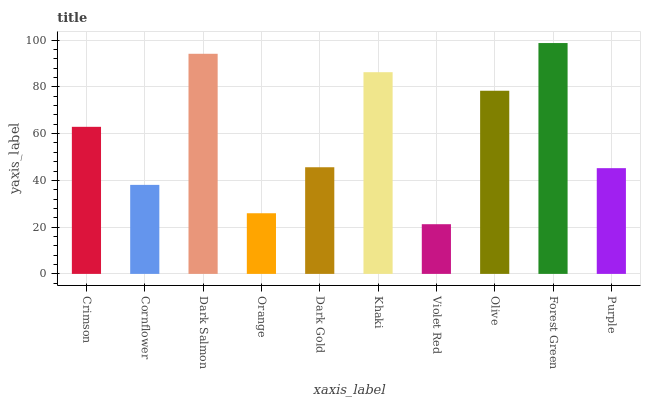Is Violet Red the minimum?
Answer yes or no. Yes. Is Forest Green the maximum?
Answer yes or no. Yes. Is Cornflower the minimum?
Answer yes or no. No. Is Cornflower the maximum?
Answer yes or no. No. Is Crimson greater than Cornflower?
Answer yes or no. Yes. Is Cornflower less than Crimson?
Answer yes or no. Yes. Is Cornflower greater than Crimson?
Answer yes or no. No. Is Crimson less than Cornflower?
Answer yes or no. No. Is Crimson the high median?
Answer yes or no. Yes. Is Dark Gold the low median?
Answer yes or no. Yes. Is Khaki the high median?
Answer yes or no. No. Is Purple the low median?
Answer yes or no. No. 